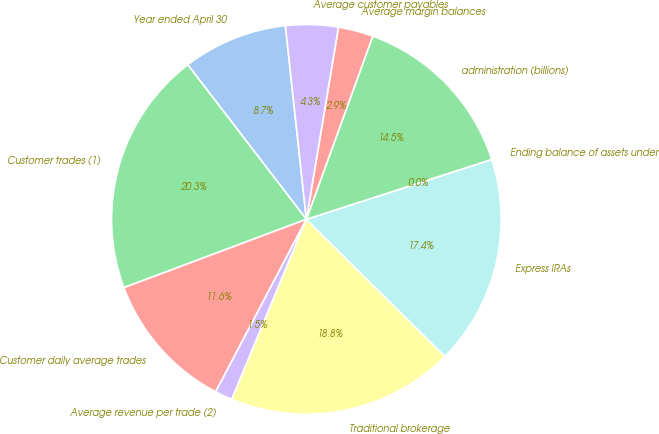Convert chart to OTSL. <chart><loc_0><loc_0><loc_500><loc_500><pie_chart><fcel>Year ended April 30<fcel>Customer trades (1)<fcel>Customer daily average trades<fcel>Average revenue per trade (2)<fcel>Traditional brokerage<fcel>Express IRAs<fcel>Ending balance of assets under<fcel>administration (billions)<fcel>Average margin balances<fcel>Average customer payables<nl><fcel>8.7%<fcel>20.29%<fcel>11.59%<fcel>1.45%<fcel>18.84%<fcel>17.39%<fcel>0.0%<fcel>14.49%<fcel>2.9%<fcel>4.35%<nl></chart> 